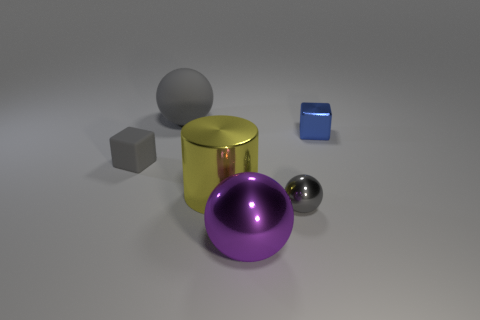There is a shiny object that is the same color as the large rubber object; what shape is it?
Make the answer very short. Sphere. What material is the large yellow cylinder?
Give a very brief answer. Metal. Is the tiny blue thing made of the same material as the small gray ball?
Make the answer very short. Yes. What number of metallic objects are large purple cylinders or spheres?
Provide a short and direct response. 2. What shape is the rubber object behind the small matte thing?
Ensure brevity in your answer.  Sphere. What is the size of the gray sphere that is made of the same material as the gray cube?
Your answer should be compact. Large. What is the shape of the large thing that is both behind the small gray metal ball and in front of the tiny gray block?
Provide a succinct answer. Cylinder. There is a ball that is left of the purple sphere; is it the same color as the small metal block?
Provide a succinct answer. No. There is a large metallic object that is behind the small sphere; does it have the same shape as the small metallic object on the left side of the tiny blue thing?
Keep it short and to the point. No. There is a block on the right side of the big rubber object; what is its size?
Your answer should be very brief. Small. 